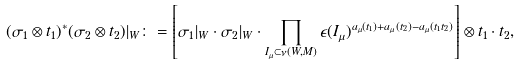Convert formula to latex. <formula><loc_0><loc_0><loc_500><loc_500>( \sigma _ { 1 } \otimes t _ { 1 } ) ^ { * } ( \sigma _ { 2 } \otimes t _ { 2 } ) | _ { W } \colon = \left [ \sigma _ { 1 } | _ { W } \cdot \sigma _ { 2 } | _ { W } \cdot \prod _ { I _ { \mu } \subset \nu ( W , M ) } \epsilon ( I _ { \mu } ) ^ { a _ { \mu } ( t _ { 1 } ) + a _ { \mu } ( t _ { 2 } ) - a _ { \mu } ( t _ { 1 } t _ { 2 } ) } \right ] \otimes t _ { 1 } \cdot t _ { 2 } ,</formula> 